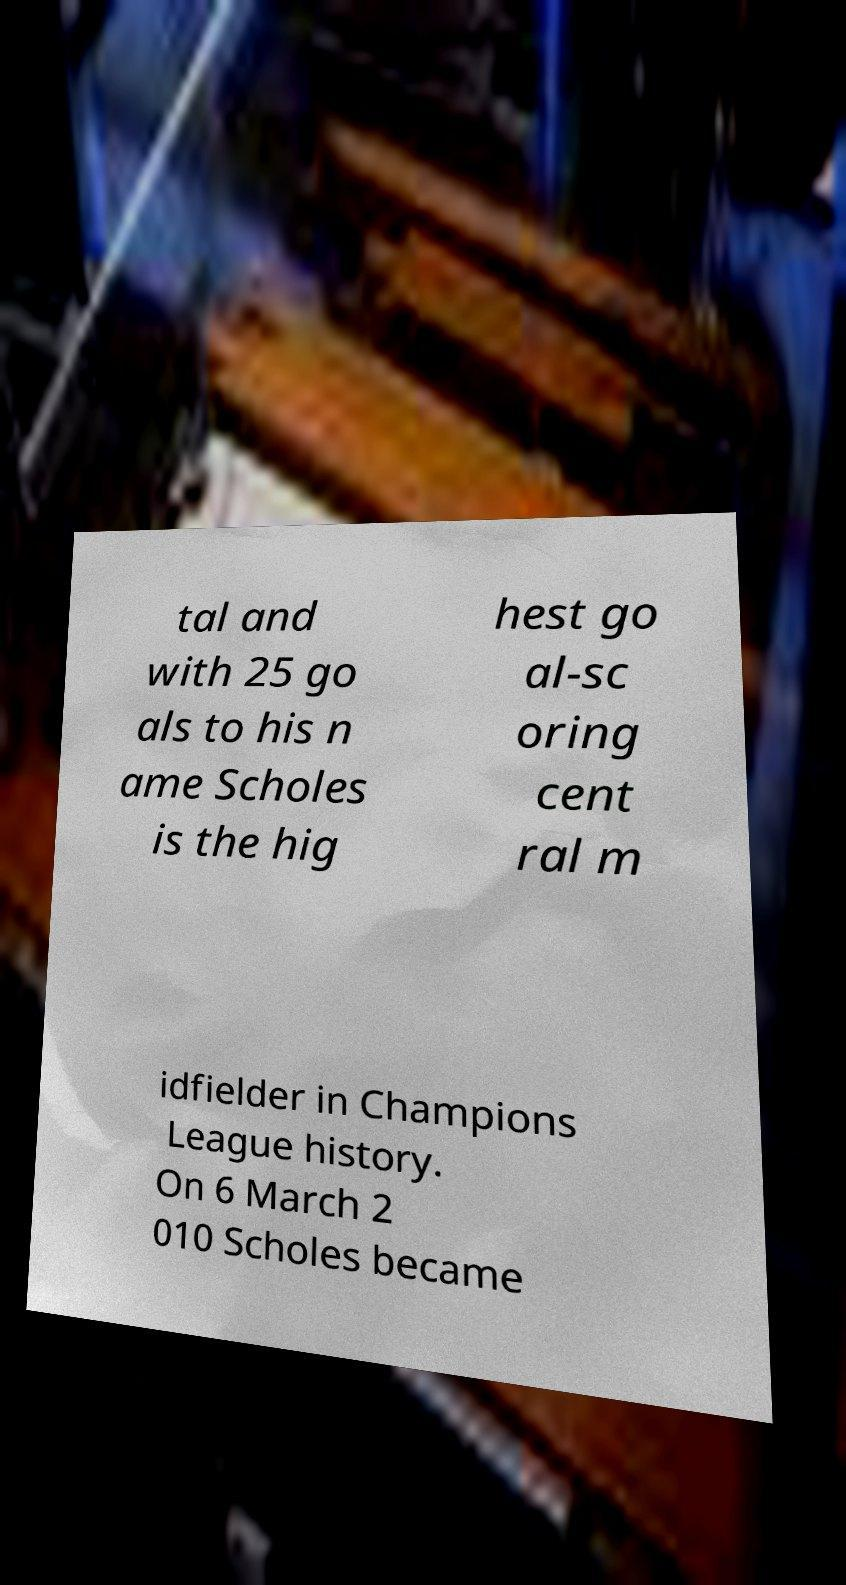Please read and relay the text visible in this image. What does it say? tal and with 25 go als to his n ame Scholes is the hig hest go al-sc oring cent ral m idfielder in Champions League history. On 6 March 2 010 Scholes became 